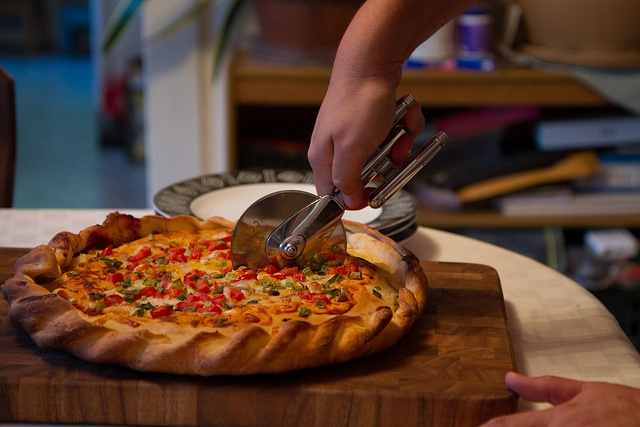Describe the objects in this image and their specific colors. I can see pizza in black, maroon, and brown tones, dining table in black, tan, gray, and darkgray tones, people in black, maroon, and brown tones, book in black, gray, and darkblue tones, and book in black and gray tones in this image. 